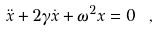<formula> <loc_0><loc_0><loc_500><loc_500>\ddot { x } + 2 \gamma \dot { x } + \omega ^ { 2 } x = 0 \ ,</formula> 